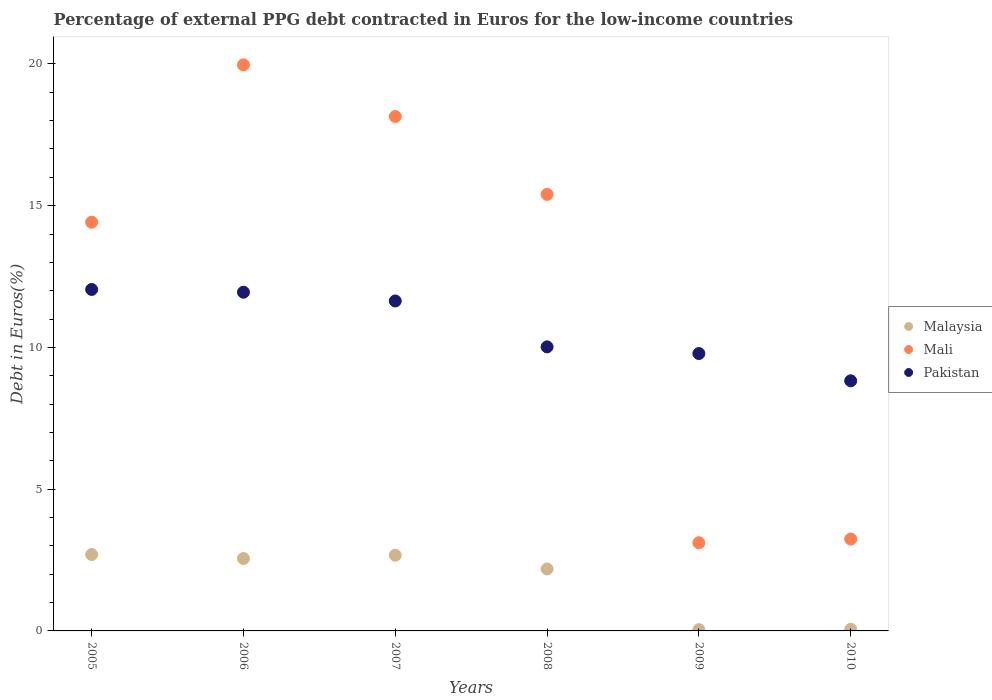What is the percentage of external PPG debt contracted in Euros in Malaysia in 2008?
Ensure brevity in your answer.  2.19. Across all years, what is the maximum percentage of external PPG debt contracted in Euros in Mali?
Give a very brief answer. 19.97. Across all years, what is the minimum percentage of external PPG debt contracted in Euros in Pakistan?
Give a very brief answer. 8.82. In which year was the percentage of external PPG debt contracted in Euros in Pakistan minimum?
Give a very brief answer. 2010. What is the total percentage of external PPG debt contracted in Euros in Mali in the graph?
Offer a terse response. 74.28. What is the difference between the percentage of external PPG debt contracted in Euros in Pakistan in 2008 and that in 2010?
Offer a terse response. 1.2. What is the difference between the percentage of external PPG debt contracted in Euros in Pakistan in 2010 and the percentage of external PPG debt contracted in Euros in Malaysia in 2007?
Your response must be concise. 6.15. What is the average percentage of external PPG debt contracted in Euros in Malaysia per year?
Provide a succinct answer. 1.7. In the year 2005, what is the difference between the percentage of external PPG debt contracted in Euros in Malaysia and percentage of external PPG debt contracted in Euros in Pakistan?
Your answer should be compact. -9.35. In how many years, is the percentage of external PPG debt contracted in Euros in Pakistan greater than 9 %?
Your answer should be compact. 5. What is the ratio of the percentage of external PPG debt contracted in Euros in Pakistan in 2006 to that in 2007?
Give a very brief answer. 1.03. Is the percentage of external PPG debt contracted in Euros in Pakistan in 2005 less than that in 2010?
Keep it short and to the point. No. What is the difference between the highest and the second highest percentage of external PPG debt contracted in Euros in Pakistan?
Offer a terse response. 0.1. What is the difference between the highest and the lowest percentage of external PPG debt contracted in Euros in Pakistan?
Your response must be concise. 3.22. Does the percentage of external PPG debt contracted in Euros in Mali monotonically increase over the years?
Provide a succinct answer. No. Is the percentage of external PPG debt contracted in Euros in Mali strictly greater than the percentage of external PPG debt contracted in Euros in Pakistan over the years?
Give a very brief answer. No. Is the percentage of external PPG debt contracted in Euros in Mali strictly less than the percentage of external PPG debt contracted in Euros in Pakistan over the years?
Your response must be concise. No. What is the difference between two consecutive major ticks on the Y-axis?
Your answer should be very brief. 5. Where does the legend appear in the graph?
Make the answer very short. Center right. How are the legend labels stacked?
Your answer should be compact. Vertical. What is the title of the graph?
Offer a terse response. Percentage of external PPG debt contracted in Euros for the low-income countries. Does "Papua New Guinea" appear as one of the legend labels in the graph?
Give a very brief answer. No. What is the label or title of the X-axis?
Provide a succinct answer. Years. What is the label or title of the Y-axis?
Your answer should be very brief. Debt in Euros(%). What is the Debt in Euros(%) of Malaysia in 2005?
Provide a succinct answer. 2.69. What is the Debt in Euros(%) in Mali in 2005?
Provide a succinct answer. 14.42. What is the Debt in Euros(%) in Pakistan in 2005?
Make the answer very short. 12.04. What is the Debt in Euros(%) in Malaysia in 2006?
Keep it short and to the point. 2.55. What is the Debt in Euros(%) of Mali in 2006?
Your answer should be compact. 19.97. What is the Debt in Euros(%) in Pakistan in 2006?
Provide a succinct answer. 11.95. What is the Debt in Euros(%) in Malaysia in 2007?
Give a very brief answer. 2.67. What is the Debt in Euros(%) of Mali in 2007?
Make the answer very short. 18.15. What is the Debt in Euros(%) in Pakistan in 2007?
Offer a very short reply. 11.64. What is the Debt in Euros(%) in Malaysia in 2008?
Your answer should be compact. 2.19. What is the Debt in Euros(%) in Mali in 2008?
Your answer should be compact. 15.4. What is the Debt in Euros(%) of Pakistan in 2008?
Ensure brevity in your answer.  10.02. What is the Debt in Euros(%) in Malaysia in 2009?
Give a very brief answer. 0.04. What is the Debt in Euros(%) of Mali in 2009?
Give a very brief answer. 3.11. What is the Debt in Euros(%) in Pakistan in 2009?
Give a very brief answer. 9.78. What is the Debt in Euros(%) in Malaysia in 2010?
Your answer should be compact. 0.06. What is the Debt in Euros(%) of Mali in 2010?
Provide a short and direct response. 3.24. What is the Debt in Euros(%) in Pakistan in 2010?
Provide a succinct answer. 8.82. Across all years, what is the maximum Debt in Euros(%) in Malaysia?
Your response must be concise. 2.69. Across all years, what is the maximum Debt in Euros(%) in Mali?
Provide a short and direct response. 19.97. Across all years, what is the maximum Debt in Euros(%) of Pakistan?
Provide a short and direct response. 12.04. Across all years, what is the minimum Debt in Euros(%) in Malaysia?
Ensure brevity in your answer.  0.04. Across all years, what is the minimum Debt in Euros(%) of Mali?
Make the answer very short. 3.11. Across all years, what is the minimum Debt in Euros(%) of Pakistan?
Keep it short and to the point. 8.82. What is the total Debt in Euros(%) in Malaysia in the graph?
Ensure brevity in your answer.  10.21. What is the total Debt in Euros(%) in Mali in the graph?
Ensure brevity in your answer.  74.28. What is the total Debt in Euros(%) in Pakistan in the graph?
Make the answer very short. 64.26. What is the difference between the Debt in Euros(%) in Malaysia in 2005 and that in 2006?
Offer a terse response. 0.14. What is the difference between the Debt in Euros(%) of Mali in 2005 and that in 2006?
Ensure brevity in your answer.  -5.55. What is the difference between the Debt in Euros(%) in Pakistan in 2005 and that in 2006?
Your answer should be very brief. 0.1. What is the difference between the Debt in Euros(%) in Malaysia in 2005 and that in 2007?
Your answer should be compact. 0.02. What is the difference between the Debt in Euros(%) of Mali in 2005 and that in 2007?
Ensure brevity in your answer.  -3.73. What is the difference between the Debt in Euros(%) of Pakistan in 2005 and that in 2007?
Your answer should be compact. 0.41. What is the difference between the Debt in Euros(%) in Malaysia in 2005 and that in 2008?
Offer a very short reply. 0.51. What is the difference between the Debt in Euros(%) of Mali in 2005 and that in 2008?
Offer a terse response. -0.98. What is the difference between the Debt in Euros(%) in Pakistan in 2005 and that in 2008?
Ensure brevity in your answer.  2.02. What is the difference between the Debt in Euros(%) in Malaysia in 2005 and that in 2009?
Provide a succinct answer. 2.65. What is the difference between the Debt in Euros(%) of Mali in 2005 and that in 2009?
Your response must be concise. 11.3. What is the difference between the Debt in Euros(%) in Pakistan in 2005 and that in 2009?
Make the answer very short. 2.26. What is the difference between the Debt in Euros(%) in Malaysia in 2005 and that in 2010?
Ensure brevity in your answer.  2.64. What is the difference between the Debt in Euros(%) in Mali in 2005 and that in 2010?
Offer a very short reply. 11.18. What is the difference between the Debt in Euros(%) in Pakistan in 2005 and that in 2010?
Offer a very short reply. 3.22. What is the difference between the Debt in Euros(%) in Malaysia in 2006 and that in 2007?
Make the answer very short. -0.12. What is the difference between the Debt in Euros(%) of Mali in 2006 and that in 2007?
Keep it short and to the point. 1.82. What is the difference between the Debt in Euros(%) of Pakistan in 2006 and that in 2007?
Offer a terse response. 0.31. What is the difference between the Debt in Euros(%) in Malaysia in 2006 and that in 2008?
Your answer should be compact. 0.37. What is the difference between the Debt in Euros(%) of Mali in 2006 and that in 2008?
Ensure brevity in your answer.  4.57. What is the difference between the Debt in Euros(%) in Pakistan in 2006 and that in 2008?
Your answer should be compact. 1.93. What is the difference between the Debt in Euros(%) in Malaysia in 2006 and that in 2009?
Offer a very short reply. 2.51. What is the difference between the Debt in Euros(%) in Mali in 2006 and that in 2009?
Make the answer very short. 16.86. What is the difference between the Debt in Euros(%) of Pakistan in 2006 and that in 2009?
Your answer should be compact. 2.16. What is the difference between the Debt in Euros(%) of Malaysia in 2006 and that in 2010?
Offer a very short reply. 2.5. What is the difference between the Debt in Euros(%) in Mali in 2006 and that in 2010?
Your answer should be very brief. 16.73. What is the difference between the Debt in Euros(%) of Pakistan in 2006 and that in 2010?
Your answer should be compact. 3.12. What is the difference between the Debt in Euros(%) of Malaysia in 2007 and that in 2008?
Your response must be concise. 0.49. What is the difference between the Debt in Euros(%) of Mali in 2007 and that in 2008?
Provide a succinct answer. 2.75. What is the difference between the Debt in Euros(%) of Pakistan in 2007 and that in 2008?
Give a very brief answer. 1.62. What is the difference between the Debt in Euros(%) in Malaysia in 2007 and that in 2009?
Offer a very short reply. 2.63. What is the difference between the Debt in Euros(%) in Mali in 2007 and that in 2009?
Your answer should be compact. 15.03. What is the difference between the Debt in Euros(%) of Pakistan in 2007 and that in 2009?
Give a very brief answer. 1.85. What is the difference between the Debt in Euros(%) of Malaysia in 2007 and that in 2010?
Offer a terse response. 2.61. What is the difference between the Debt in Euros(%) in Mali in 2007 and that in 2010?
Offer a terse response. 14.91. What is the difference between the Debt in Euros(%) in Pakistan in 2007 and that in 2010?
Give a very brief answer. 2.82. What is the difference between the Debt in Euros(%) in Malaysia in 2008 and that in 2009?
Ensure brevity in your answer.  2.14. What is the difference between the Debt in Euros(%) of Mali in 2008 and that in 2009?
Your response must be concise. 12.29. What is the difference between the Debt in Euros(%) in Pakistan in 2008 and that in 2009?
Provide a short and direct response. 0.24. What is the difference between the Debt in Euros(%) in Malaysia in 2008 and that in 2010?
Your answer should be compact. 2.13. What is the difference between the Debt in Euros(%) of Mali in 2008 and that in 2010?
Keep it short and to the point. 12.16. What is the difference between the Debt in Euros(%) in Pakistan in 2008 and that in 2010?
Keep it short and to the point. 1.2. What is the difference between the Debt in Euros(%) of Malaysia in 2009 and that in 2010?
Your response must be concise. -0.01. What is the difference between the Debt in Euros(%) of Mali in 2009 and that in 2010?
Your response must be concise. -0.13. What is the difference between the Debt in Euros(%) of Pakistan in 2009 and that in 2010?
Give a very brief answer. 0.96. What is the difference between the Debt in Euros(%) in Malaysia in 2005 and the Debt in Euros(%) in Mali in 2006?
Your answer should be compact. -17.27. What is the difference between the Debt in Euros(%) in Malaysia in 2005 and the Debt in Euros(%) in Pakistan in 2006?
Your response must be concise. -9.25. What is the difference between the Debt in Euros(%) in Mali in 2005 and the Debt in Euros(%) in Pakistan in 2006?
Offer a very short reply. 2.47. What is the difference between the Debt in Euros(%) in Malaysia in 2005 and the Debt in Euros(%) in Mali in 2007?
Keep it short and to the point. -15.45. What is the difference between the Debt in Euros(%) of Malaysia in 2005 and the Debt in Euros(%) of Pakistan in 2007?
Your answer should be very brief. -8.94. What is the difference between the Debt in Euros(%) of Mali in 2005 and the Debt in Euros(%) of Pakistan in 2007?
Your answer should be very brief. 2.78. What is the difference between the Debt in Euros(%) of Malaysia in 2005 and the Debt in Euros(%) of Mali in 2008?
Make the answer very short. -12.7. What is the difference between the Debt in Euros(%) in Malaysia in 2005 and the Debt in Euros(%) in Pakistan in 2008?
Make the answer very short. -7.33. What is the difference between the Debt in Euros(%) in Mali in 2005 and the Debt in Euros(%) in Pakistan in 2008?
Your answer should be compact. 4.4. What is the difference between the Debt in Euros(%) of Malaysia in 2005 and the Debt in Euros(%) of Mali in 2009?
Your answer should be very brief. -0.42. What is the difference between the Debt in Euros(%) of Malaysia in 2005 and the Debt in Euros(%) of Pakistan in 2009?
Keep it short and to the point. -7.09. What is the difference between the Debt in Euros(%) of Mali in 2005 and the Debt in Euros(%) of Pakistan in 2009?
Give a very brief answer. 4.63. What is the difference between the Debt in Euros(%) of Malaysia in 2005 and the Debt in Euros(%) of Mali in 2010?
Your response must be concise. -0.55. What is the difference between the Debt in Euros(%) of Malaysia in 2005 and the Debt in Euros(%) of Pakistan in 2010?
Provide a succinct answer. -6.13. What is the difference between the Debt in Euros(%) of Mali in 2005 and the Debt in Euros(%) of Pakistan in 2010?
Your answer should be compact. 5.59. What is the difference between the Debt in Euros(%) in Malaysia in 2006 and the Debt in Euros(%) in Mali in 2007?
Your answer should be compact. -15.59. What is the difference between the Debt in Euros(%) in Malaysia in 2006 and the Debt in Euros(%) in Pakistan in 2007?
Offer a terse response. -9.09. What is the difference between the Debt in Euros(%) in Mali in 2006 and the Debt in Euros(%) in Pakistan in 2007?
Provide a succinct answer. 8.33. What is the difference between the Debt in Euros(%) of Malaysia in 2006 and the Debt in Euros(%) of Mali in 2008?
Your answer should be compact. -12.84. What is the difference between the Debt in Euros(%) of Malaysia in 2006 and the Debt in Euros(%) of Pakistan in 2008?
Give a very brief answer. -7.47. What is the difference between the Debt in Euros(%) in Mali in 2006 and the Debt in Euros(%) in Pakistan in 2008?
Give a very brief answer. 9.95. What is the difference between the Debt in Euros(%) of Malaysia in 2006 and the Debt in Euros(%) of Mali in 2009?
Keep it short and to the point. -0.56. What is the difference between the Debt in Euros(%) in Malaysia in 2006 and the Debt in Euros(%) in Pakistan in 2009?
Offer a terse response. -7.23. What is the difference between the Debt in Euros(%) of Mali in 2006 and the Debt in Euros(%) of Pakistan in 2009?
Make the answer very short. 10.18. What is the difference between the Debt in Euros(%) of Malaysia in 2006 and the Debt in Euros(%) of Mali in 2010?
Offer a very short reply. -0.69. What is the difference between the Debt in Euros(%) in Malaysia in 2006 and the Debt in Euros(%) in Pakistan in 2010?
Provide a succinct answer. -6.27. What is the difference between the Debt in Euros(%) in Mali in 2006 and the Debt in Euros(%) in Pakistan in 2010?
Provide a short and direct response. 11.15. What is the difference between the Debt in Euros(%) of Malaysia in 2007 and the Debt in Euros(%) of Mali in 2008?
Give a very brief answer. -12.73. What is the difference between the Debt in Euros(%) in Malaysia in 2007 and the Debt in Euros(%) in Pakistan in 2008?
Your answer should be very brief. -7.35. What is the difference between the Debt in Euros(%) of Mali in 2007 and the Debt in Euros(%) of Pakistan in 2008?
Keep it short and to the point. 8.13. What is the difference between the Debt in Euros(%) of Malaysia in 2007 and the Debt in Euros(%) of Mali in 2009?
Keep it short and to the point. -0.44. What is the difference between the Debt in Euros(%) of Malaysia in 2007 and the Debt in Euros(%) of Pakistan in 2009?
Give a very brief answer. -7.11. What is the difference between the Debt in Euros(%) of Mali in 2007 and the Debt in Euros(%) of Pakistan in 2009?
Your answer should be compact. 8.36. What is the difference between the Debt in Euros(%) of Malaysia in 2007 and the Debt in Euros(%) of Mali in 2010?
Offer a very short reply. -0.57. What is the difference between the Debt in Euros(%) of Malaysia in 2007 and the Debt in Euros(%) of Pakistan in 2010?
Provide a succinct answer. -6.15. What is the difference between the Debt in Euros(%) of Mali in 2007 and the Debt in Euros(%) of Pakistan in 2010?
Give a very brief answer. 9.32. What is the difference between the Debt in Euros(%) in Malaysia in 2008 and the Debt in Euros(%) in Mali in 2009?
Provide a succinct answer. -0.93. What is the difference between the Debt in Euros(%) of Malaysia in 2008 and the Debt in Euros(%) of Pakistan in 2009?
Give a very brief answer. -7.6. What is the difference between the Debt in Euros(%) of Mali in 2008 and the Debt in Euros(%) of Pakistan in 2009?
Give a very brief answer. 5.61. What is the difference between the Debt in Euros(%) of Malaysia in 2008 and the Debt in Euros(%) of Mali in 2010?
Keep it short and to the point. -1.05. What is the difference between the Debt in Euros(%) of Malaysia in 2008 and the Debt in Euros(%) of Pakistan in 2010?
Your answer should be compact. -6.64. What is the difference between the Debt in Euros(%) of Mali in 2008 and the Debt in Euros(%) of Pakistan in 2010?
Make the answer very short. 6.58. What is the difference between the Debt in Euros(%) of Malaysia in 2009 and the Debt in Euros(%) of Mali in 2010?
Your answer should be compact. -3.2. What is the difference between the Debt in Euros(%) in Malaysia in 2009 and the Debt in Euros(%) in Pakistan in 2010?
Your answer should be very brief. -8.78. What is the difference between the Debt in Euros(%) of Mali in 2009 and the Debt in Euros(%) of Pakistan in 2010?
Provide a succinct answer. -5.71. What is the average Debt in Euros(%) of Malaysia per year?
Give a very brief answer. 1.7. What is the average Debt in Euros(%) of Mali per year?
Your response must be concise. 12.38. What is the average Debt in Euros(%) of Pakistan per year?
Offer a terse response. 10.71. In the year 2005, what is the difference between the Debt in Euros(%) of Malaysia and Debt in Euros(%) of Mali?
Ensure brevity in your answer.  -11.72. In the year 2005, what is the difference between the Debt in Euros(%) in Malaysia and Debt in Euros(%) in Pakistan?
Provide a succinct answer. -9.35. In the year 2005, what is the difference between the Debt in Euros(%) of Mali and Debt in Euros(%) of Pakistan?
Ensure brevity in your answer.  2.37. In the year 2006, what is the difference between the Debt in Euros(%) of Malaysia and Debt in Euros(%) of Mali?
Offer a very short reply. -17.41. In the year 2006, what is the difference between the Debt in Euros(%) of Malaysia and Debt in Euros(%) of Pakistan?
Offer a very short reply. -9.39. In the year 2006, what is the difference between the Debt in Euros(%) of Mali and Debt in Euros(%) of Pakistan?
Ensure brevity in your answer.  8.02. In the year 2007, what is the difference between the Debt in Euros(%) in Malaysia and Debt in Euros(%) in Mali?
Offer a terse response. -15.47. In the year 2007, what is the difference between the Debt in Euros(%) in Malaysia and Debt in Euros(%) in Pakistan?
Make the answer very short. -8.97. In the year 2007, what is the difference between the Debt in Euros(%) of Mali and Debt in Euros(%) of Pakistan?
Keep it short and to the point. 6.51. In the year 2008, what is the difference between the Debt in Euros(%) of Malaysia and Debt in Euros(%) of Mali?
Make the answer very short. -13.21. In the year 2008, what is the difference between the Debt in Euros(%) in Malaysia and Debt in Euros(%) in Pakistan?
Give a very brief answer. -7.83. In the year 2008, what is the difference between the Debt in Euros(%) in Mali and Debt in Euros(%) in Pakistan?
Provide a short and direct response. 5.38. In the year 2009, what is the difference between the Debt in Euros(%) of Malaysia and Debt in Euros(%) of Mali?
Your answer should be very brief. -3.07. In the year 2009, what is the difference between the Debt in Euros(%) of Malaysia and Debt in Euros(%) of Pakistan?
Give a very brief answer. -9.74. In the year 2009, what is the difference between the Debt in Euros(%) in Mali and Debt in Euros(%) in Pakistan?
Give a very brief answer. -6.67. In the year 2010, what is the difference between the Debt in Euros(%) of Malaysia and Debt in Euros(%) of Mali?
Ensure brevity in your answer.  -3.18. In the year 2010, what is the difference between the Debt in Euros(%) in Malaysia and Debt in Euros(%) in Pakistan?
Provide a short and direct response. -8.76. In the year 2010, what is the difference between the Debt in Euros(%) of Mali and Debt in Euros(%) of Pakistan?
Provide a short and direct response. -5.58. What is the ratio of the Debt in Euros(%) in Malaysia in 2005 to that in 2006?
Ensure brevity in your answer.  1.06. What is the ratio of the Debt in Euros(%) in Mali in 2005 to that in 2006?
Ensure brevity in your answer.  0.72. What is the ratio of the Debt in Euros(%) in Malaysia in 2005 to that in 2007?
Make the answer very short. 1.01. What is the ratio of the Debt in Euros(%) of Mali in 2005 to that in 2007?
Your answer should be very brief. 0.79. What is the ratio of the Debt in Euros(%) of Pakistan in 2005 to that in 2007?
Ensure brevity in your answer.  1.03. What is the ratio of the Debt in Euros(%) in Malaysia in 2005 to that in 2008?
Your answer should be compact. 1.23. What is the ratio of the Debt in Euros(%) of Mali in 2005 to that in 2008?
Offer a terse response. 0.94. What is the ratio of the Debt in Euros(%) in Pakistan in 2005 to that in 2008?
Your answer should be very brief. 1.2. What is the ratio of the Debt in Euros(%) of Malaysia in 2005 to that in 2009?
Provide a succinct answer. 62.24. What is the ratio of the Debt in Euros(%) of Mali in 2005 to that in 2009?
Your answer should be compact. 4.63. What is the ratio of the Debt in Euros(%) of Pakistan in 2005 to that in 2009?
Offer a very short reply. 1.23. What is the ratio of the Debt in Euros(%) of Malaysia in 2005 to that in 2010?
Keep it short and to the point. 46.62. What is the ratio of the Debt in Euros(%) in Mali in 2005 to that in 2010?
Offer a very short reply. 4.45. What is the ratio of the Debt in Euros(%) in Pakistan in 2005 to that in 2010?
Make the answer very short. 1.37. What is the ratio of the Debt in Euros(%) of Malaysia in 2006 to that in 2007?
Ensure brevity in your answer.  0.96. What is the ratio of the Debt in Euros(%) in Mali in 2006 to that in 2007?
Make the answer very short. 1.1. What is the ratio of the Debt in Euros(%) in Pakistan in 2006 to that in 2007?
Provide a succinct answer. 1.03. What is the ratio of the Debt in Euros(%) in Malaysia in 2006 to that in 2008?
Provide a succinct answer. 1.17. What is the ratio of the Debt in Euros(%) of Mali in 2006 to that in 2008?
Offer a very short reply. 1.3. What is the ratio of the Debt in Euros(%) of Pakistan in 2006 to that in 2008?
Make the answer very short. 1.19. What is the ratio of the Debt in Euros(%) in Malaysia in 2006 to that in 2009?
Give a very brief answer. 58.98. What is the ratio of the Debt in Euros(%) of Mali in 2006 to that in 2009?
Your answer should be very brief. 6.42. What is the ratio of the Debt in Euros(%) in Pakistan in 2006 to that in 2009?
Your answer should be very brief. 1.22. What is the ratio of the Debt in Euros(%) in Malaysia in 2006 to that in 2010?
Offer a terse response. 44.18. What is the ratio of the Debt in Euros(%) of Mali in 2006 to that in 2010?
Ensure brevity in your answer.  6.16. What is the ratio of the Debt in Euros(%) of Pakistan in 2006 to that in 2010?
Keep it short and to the point. 1.35. What is the ratio of the Debt in Euros(%) of Malaysia in 2007 to that in 2008?
Make the answer very short. 1.22. What is the ratio of the Debt in Euros(%) in Mali in 2007 to that in 2008?
Provide a short and direct response. 1.18. What is the ratio of the Debt in Euros(%) in Pakistan in 2007 to that in 2008?
Provide a succinct answer. 1.16. What is the ratio of the Debt in Euros(%) in Malaysia in 2007 to that in 2009?
Provide a short and direct response. 61.68. What is the ratio of the Debt in Euros(%) of Mali in 2007 to that in 2009?
Keep it short and to the point. 5.83. What is the ratio of the Debt in Euros(%) of Pakistan in 2007 to that in 2009?
Offer a terse response. 1.19. What is the ratio of the Debt in Euros(%) in Malaysia in 2007 to that in 2010?
Your answer should be compact. 46.21. What is the ratio of the Debt in Euros(%) of Mali in 2007 to that in 2010?
Provide a succinct answer. 5.6. What is the ratio of the Debt in Euros(%) in Pakistan in 2007 to that in 2010?
Your response must be concise. 1.32. What is the ratio of the Debt in Euros(%) in Malaysia in 2008 to that in 2009?
Your answer should be very brief. 50.47. What is the ratio of the Debt in Euros(%) of Mali in 2008 to that in 2009?
Provide a short and direct response. 4.95. What is the ratio of the Debt in Euros(%) of Malaysia in 2008 to that in 2010?
Your answer should be very brief. 37.81. What is the ratio of the Debt in Euros(%) of Mali in 2008 to that in 2010?
Ensure brevity in your answer.  4.75. What is the ratio of the Debt in Euros(%) in Pakistan in 2008 to that in 2010?
Make the answer very short. 1.14. What is the ratio of the Debt in Euros(%) in Malaysia in 2009 to that in 2010?
Provide a succinct answer. 0.75. What is the ratio of the Debt in Euros(%) in Mali in 2009 to that in 2010?
Your answer should be very brief. 0.96. What is the ratio of the Debt in Euros(%) of Pakistan in 2009 to that in 2010?
Your response must be concise. 1.11. What is the difference between the highest and the second highest Debt in Euros(%) of Malaysia?
Provide a succinct answer. 0.02. What is the difference between the highest and the second highest Debt in Euros(%) in Mali?
Provide a succinct answer. 1.82. What is the difference between the highest and the second highest Debt in Euros(%) in Pakistan?
Provide a succinct answer. 0.1. What is the difference between the highest and the lowest Debt in Euros(%) in Malaysia?
Your answer should be compact. 2.65. What is the difference between the highest and the lowest Debt in Euros(%) of Mali?
Keep it short and to the point. 16.86. What is the difference between the highest and the lowest Debt in Euros(%) in Pakistan?
Ensure brevity in your answer.  3.22. 